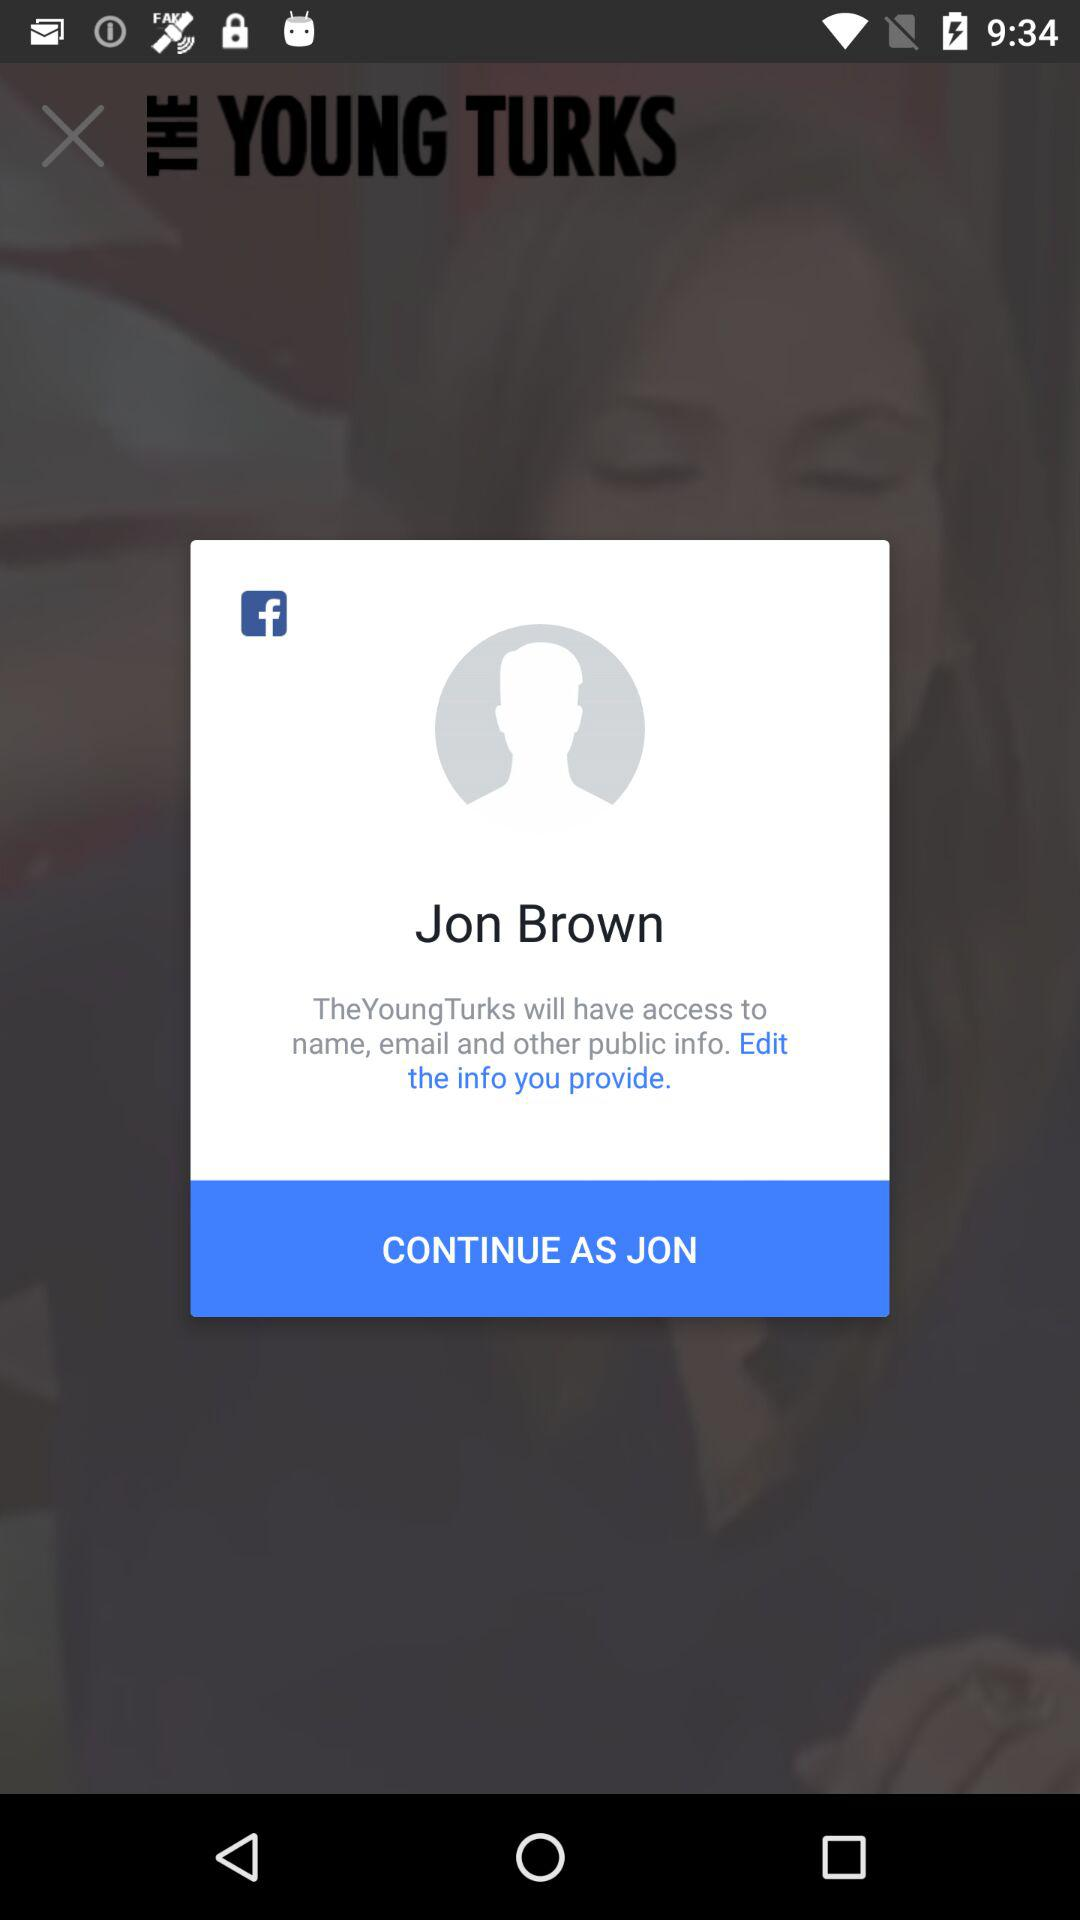What is the user name? The user name is Jon Brown. 